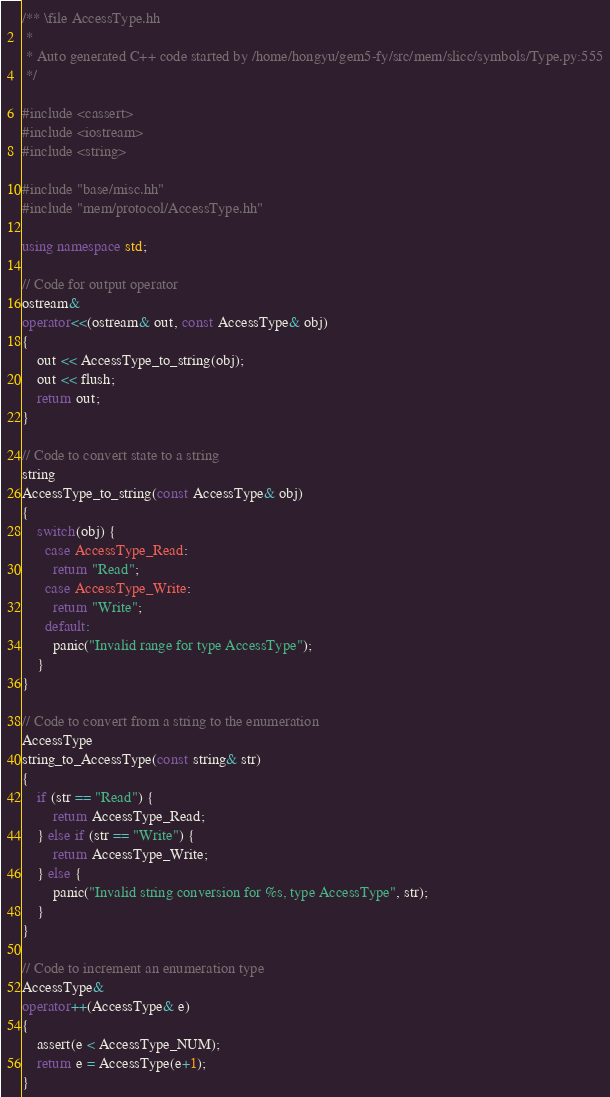Convert code to text. <code><loc_0><loc_0><loc_500><loc_500><_C++_>/** \file AccessType.hh
 *
 * Auto generated C++ code started by /home/hongyu/gem5-fy/src/mem/slicc/symbols/Type.py:555
 */

#include <cassert>
#include <iostream>
#include <string>

#include "base/misc.hh"
#include "mem/protocol/AccessType.hh"

using namespace std;

// Code for output operator
ostream&
operator<<(ostream& out, const AccessType& obj)
{
    out << AccessType_to_string(obj);
    out << flush;
    return out;
}

// Code to convert state to a string
string
AccessType_to_string(const AccessType& obj)
{
    switch(obj) {
      case AccessType_Read:
        return "Read";
      case AccessType_Write:
        return "Write";
      default:
        panic("Invalid range for type AccessType");
    }
}

// Code to convert from a string to the enumeration
AccessType
string_to_AccessType(const string& str)
{
    if (str == "Read") {
        return AccessType_Read;
    } else if (str == "Write") {
        return AccessType_Write;
    } else {
        panic("Invalid string conversion for %s, type AccessType", str);
    }
}

// Code to increment an enumeration type
AccessType&
operator++(AccessType& e)
{
    assert(e < AccessType_NUM);
    return e = AccessType(e+1);
}
</code> 